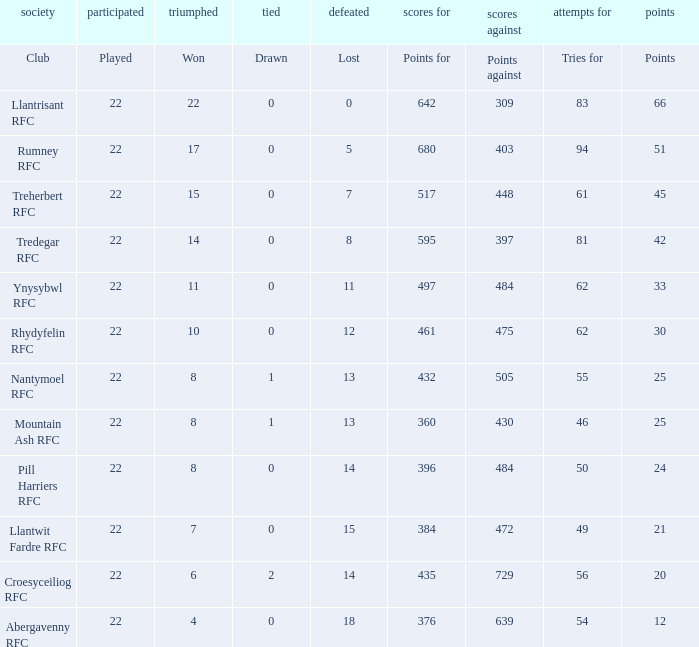How many matches were won by the teams that scored exactly 61 tries for? 15.0. 